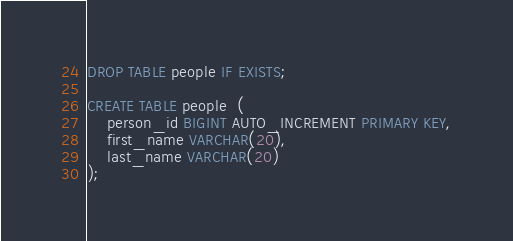<code> <loc_0><loc_0><loc_500><loc_500><_SQL_>DROP TABLE people IF EXISTS;

CREATE TABLE people  (
    person_id BIGINT AUTO_INCREMENT PRIMARY KEY,
    first_name VARCHAR(20),
    last_name VARCHAR(20)
);
</code> 